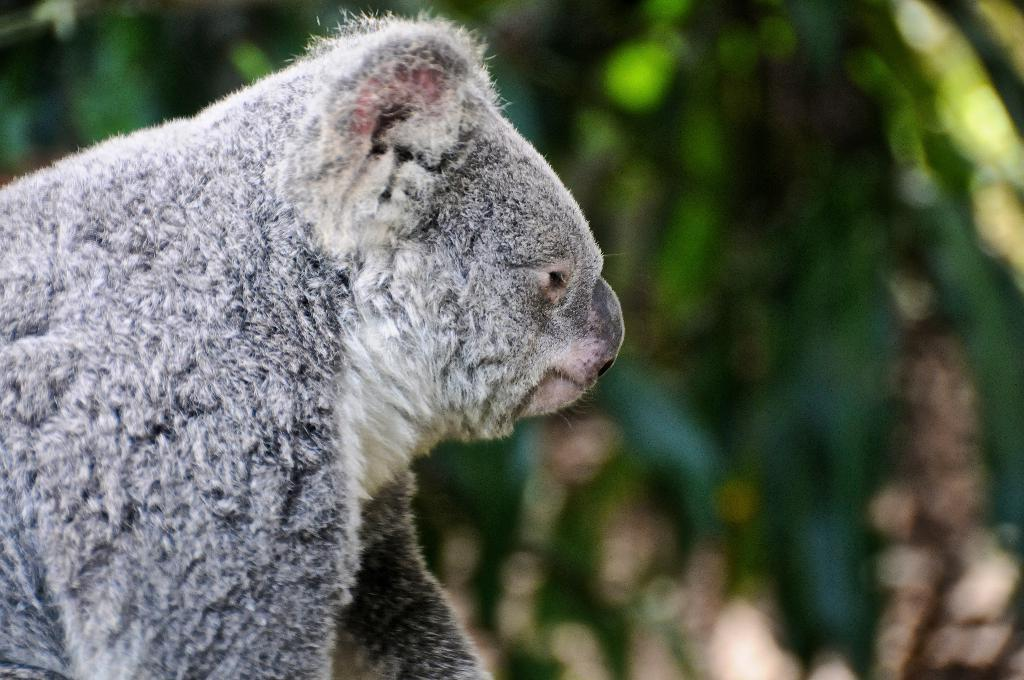What type of animal is in the image? The specific type of animal cannot be determined from the provided facts. What can be said about the background of the image? The background of the image is blurred. What type of feast is being prepared in the image? There is no indication of a feast or any food preparation in the image. What is the minister doing in the image? There is no mention of a minister or any person in the image. 